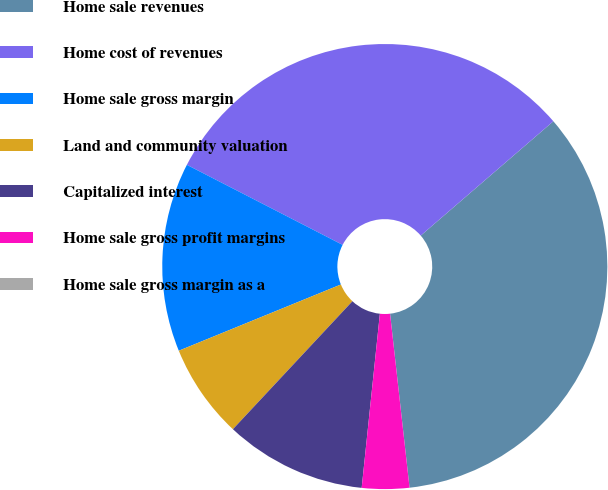Convert chart. <chart><loc_0><loc_0><loc_500><loc_500><pie_chart><fcel>Home sale revenues<fcel>Home cost of revenues<fcel>Home sale gross margin<fcel>Land and community valuation<fcel>Capitalized interest<fcel>Home sale gross profit margins<fcel>Home sale gross margin as a<nl><fcel>34.55%<fcel>31.12%<fcel>13.73%<fcel>6.87%<fcel>10.3%<fcel>3.43%<fcel>0.0%<nl></chart> 